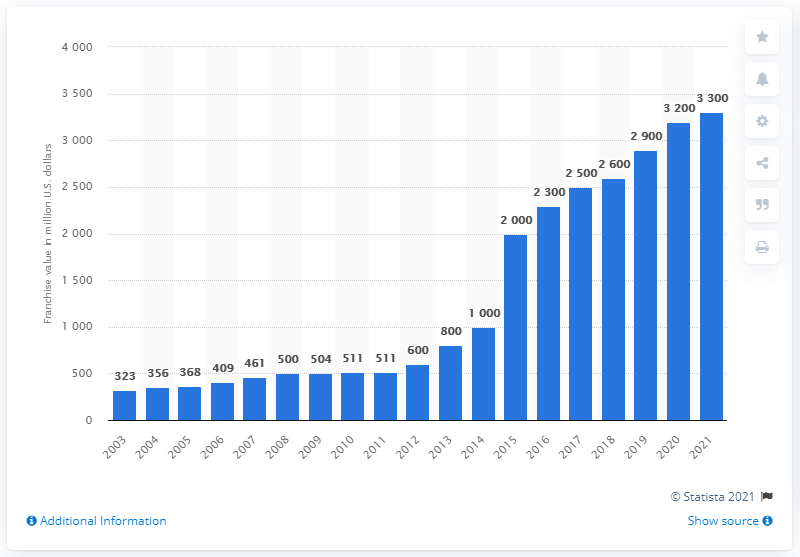What does the sudden increase in franchise value in the years 2014-2015 and 2020-2021 suggest? The sharp rises in franchise value during 2014-2015 and 2020-2021 could suggest a variety of underlying factors. Such peaks are often associated with strategic changes, like new revenue streams or sponsorship deals. For 2020-2021, the increase might also reflect the impact of new broadcasting agreements or recovery and growth in the sports industry after a downturn, likely influenced by recent global events affecting the economy and sports leagues. 